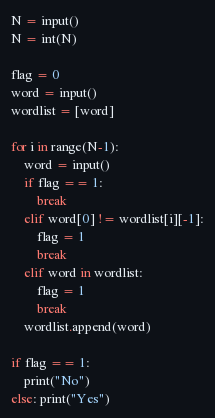<code> <loc_0><loc_0><loc_500><loc_500><_Python_>N = input()
N = int(N)

flag = 0
word = input()
wordlist = [word]

for i in range(N-1):
    word = input()
    if flag == 1:
        break
    elif word[0] != wordlist[i][-1]:
        flag = 1
        break
    elif word in wordlist:
        flag = 1
        break
    wordlist.append(word)

if flag == 1:
    print("No")
else: print("Yes")
</code> 